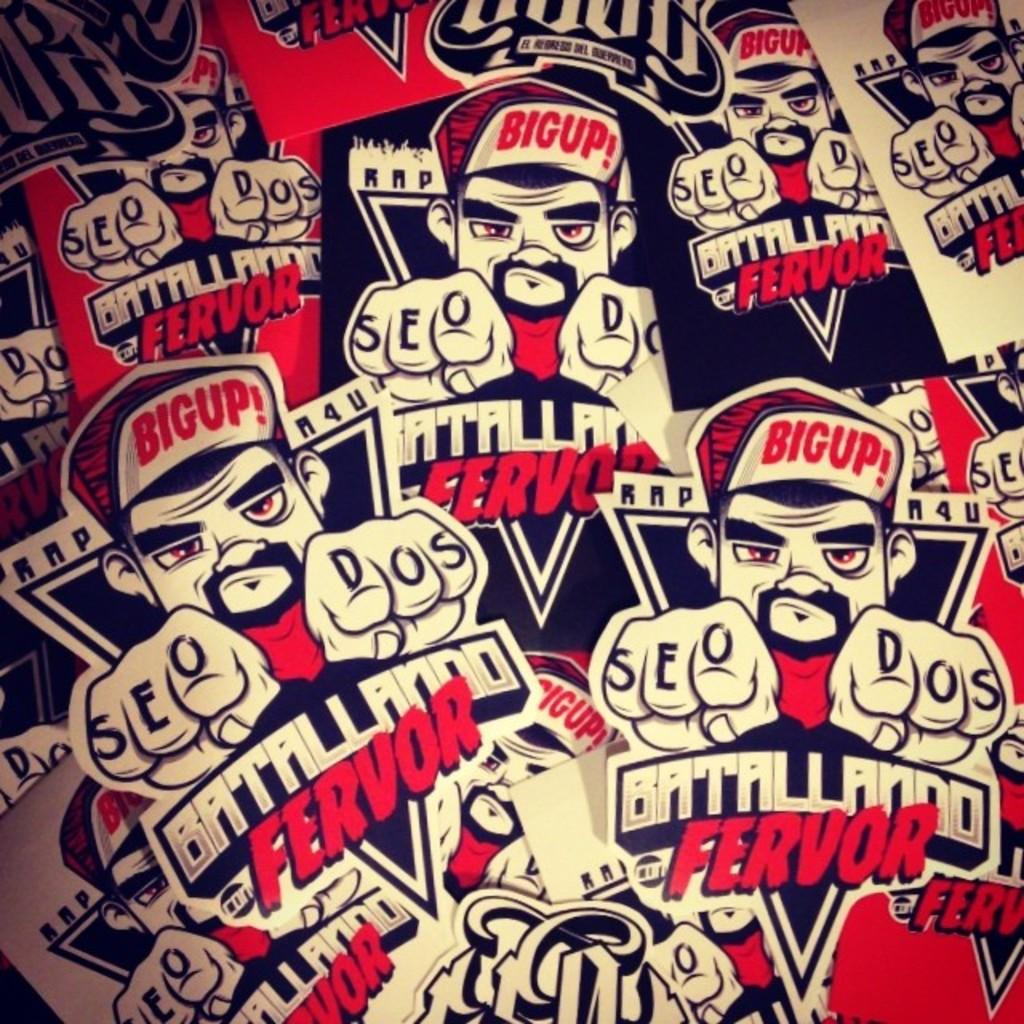<image>
Relay a brief, clear account of the picture shown. Several decals that say Batallando Ferfor are piled up together. 